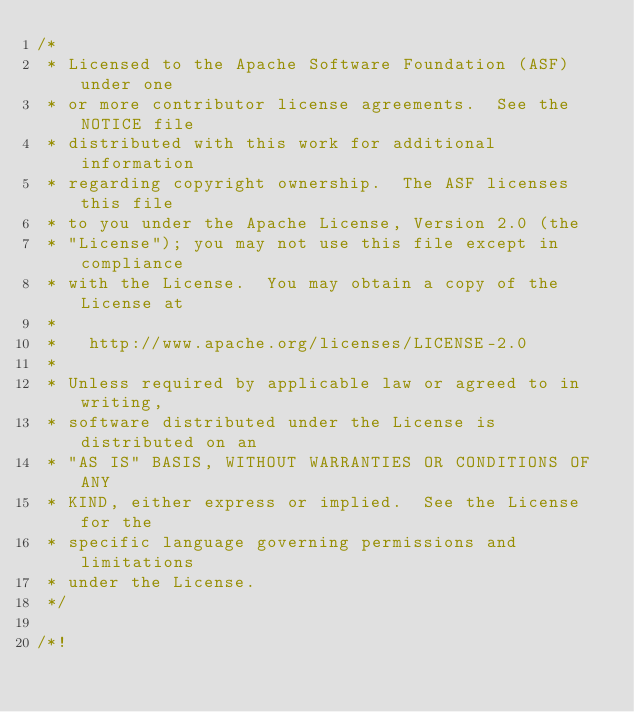<code> <loc_0><loc_0><loc_500><loc_500><_C++_>/*
 * Licensed to the Apache Software Foundation (ASF) under one
 * or more contributor license agreements.  See the NOTICE file
 * distributed with this work for additional information
 * regarding copyright ownership.  The ASF licenses this file
 * to you under the Apache License, Version 2.0 (the
 * "License"); you may not use this file except in compliance
 * with the License.  You may obtain a copy of the License at
 *
 *   http://www.apache.org/licenses/LICENSE-2.0
 *
 * Unless required by applicable law or agreed to in writing,
 * software distributed under the License is distributed on an
 * "AS IS" BASIS, WITHOUT WARRANTIES OR CONDITIONS OF ANY
 * KIND, either express or implied.  See the License for the
 * specific language governing permissions and limitations
 * under the License.
 */

/*!</code> 